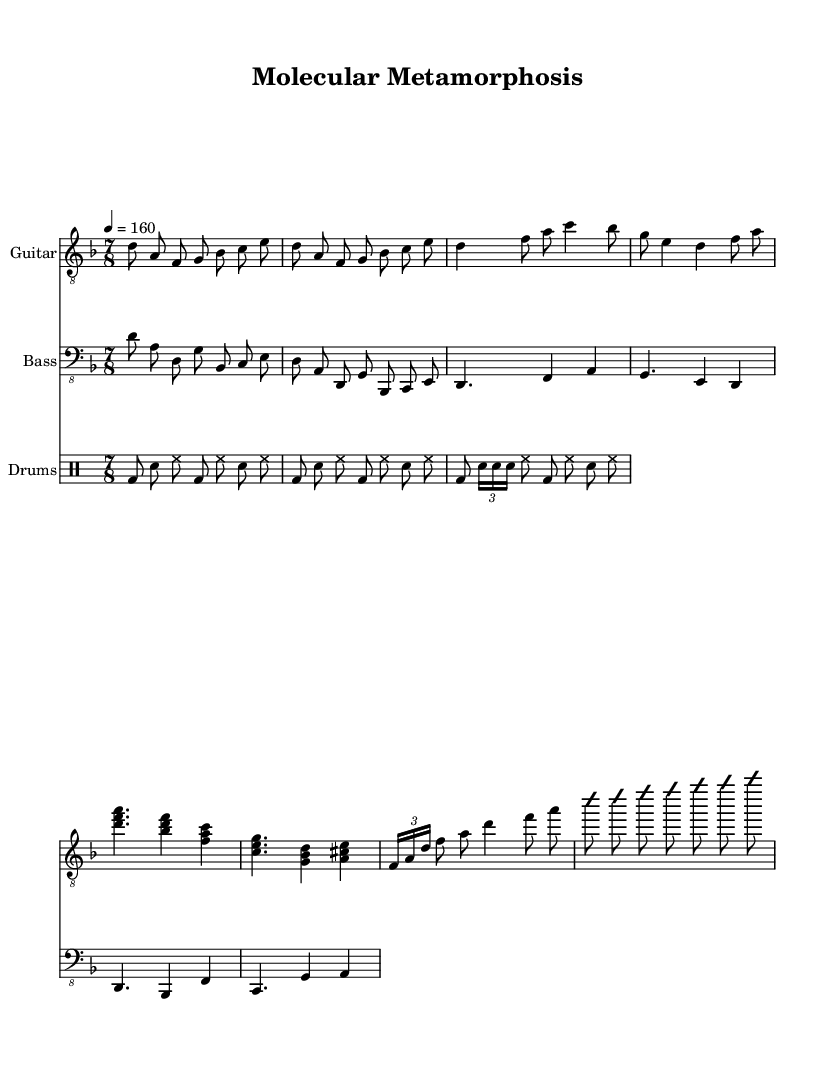What is the key signature of this music? The key signature is indicated by the number of sharps or flats at the beginning of the staff. Here, it shows a B-flat and E-flat indicating that it is in D minor, which is the relative minor of F major.
Answer: D minor What is the time signature of this music? The time signature is displayed at the beginning of the staff and shows how the beats are divided in each measure. Here, it indicates 7/8, meaning there are 7 beats per measure and the eighth note gets one beat.
Answer: 7/8 What is the tempo of this piece? The tempo is marked at the beginning of the score, showing the speed at which the music should be played. Here, it indicates that the tempo is 160 beats per minute.
Answer: 160 What is the structure of the main riff? The main riff can be identified by looking for the repeat signs and the notation in the electric guitar part. The main riff consists of two repetitions of the sequence "D, A, F, G, B-flat, C, E."
Answer: D, A, F, G, B-flat, C, E How many sections are there in this composition? To answer this, we analyze the parts of the score, including the main riff, verse, chorus, and bridge sections. This structure suggests there are four distinct sections in the composition: the main riff, verse, chorus, and bridge.
Answer: Four What type of scale is suggested for the solo? The solo hint indicates a specific scale to be used during the improvisation. In this case, it mentions the D Phrygian Dominant scale, which is a characteristic scale in metal music often used for improvisation.
Answer: D Phrygian Dominant 